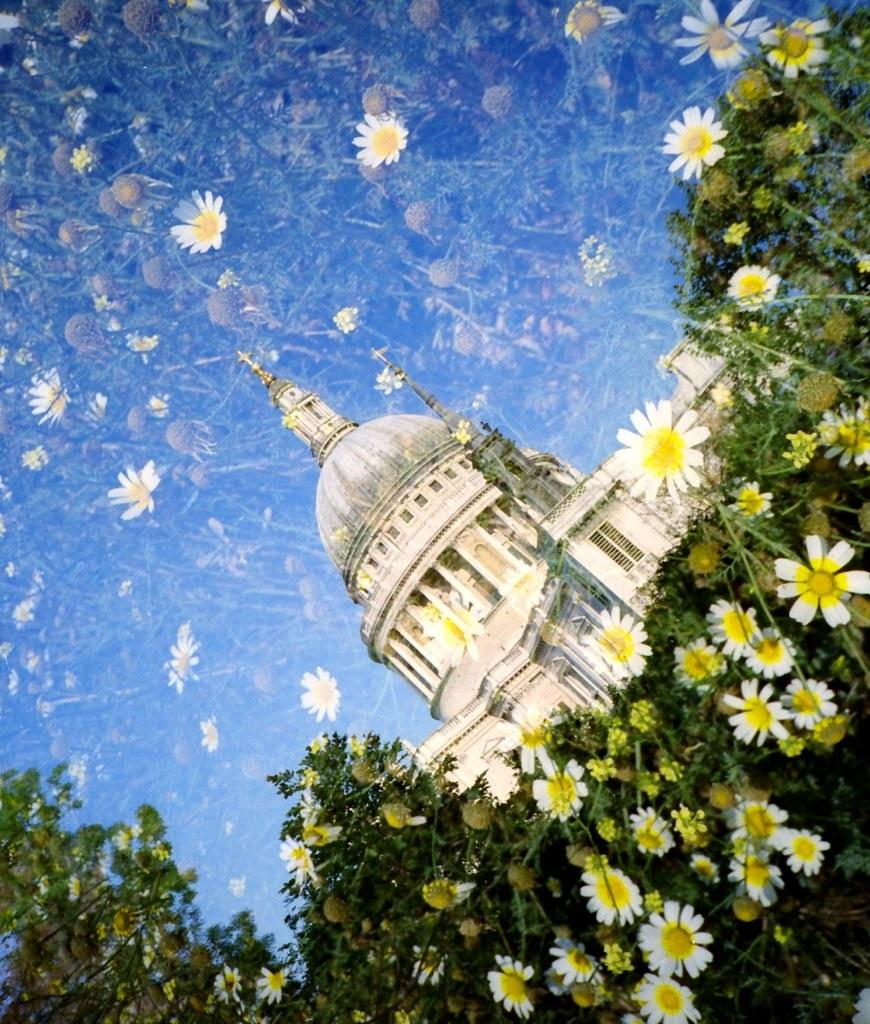What type of flora can be seen in the image? There are flowers and plants in the image. What type of structure is present in the image? There is a building in the image. What type of advertisement can be seen on the bat in the image? There is no bat present in the image, so there cannot be an advertisement on it. 